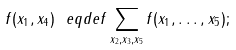<formula> <loc_0><loc_0><loc_500><loc_500>f ( x _ { 1 } , x _ { 4 } ) \ e q d e f \sum _ { x _ { 2 } , x _ { 3 } , x _ { 5 } } f ( x _ { 1 } , \dots , x _ { 5 } ) ;</formula> 